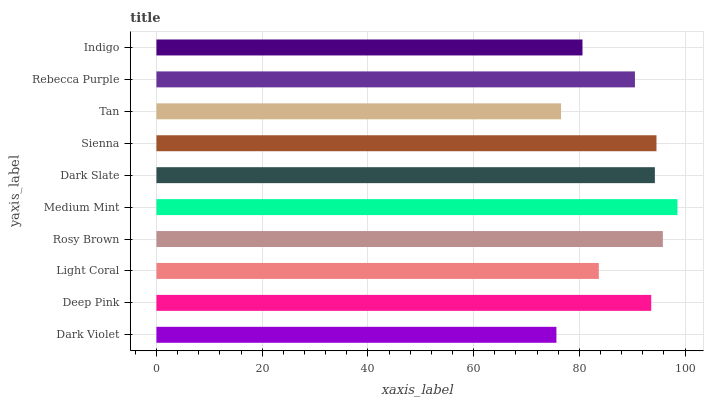Is Dark Violet the minimum?
Answer yes or no. Yes. Is Medium Mint the maximum?
Answer yes or no. Yes. Is Deep Pink the minimum?
Answer yes or no. No. Is Deep Pink the maximum?
Answer yes or no. No. Is Deep Pink greater than Dark Violet?
Answer yes or no. Yes. Is Dark Violet less than Deep Pink?
Answer yes or no. Yes. Is Dark Violet greater than Deep Pink?
Answer yes or no. No. Is Deep Pink less than Dark Violet?
Answer yes or no. No. Is Deep Pink the high median?
Answer yes or no. Yes. Is Rebecca Purple the low median?
Answer yes or no. Yes. Is Rosy Brown the high median?
Answer yes or no. No. Is Medium Mint the low median?
Answer yes or no. No. 